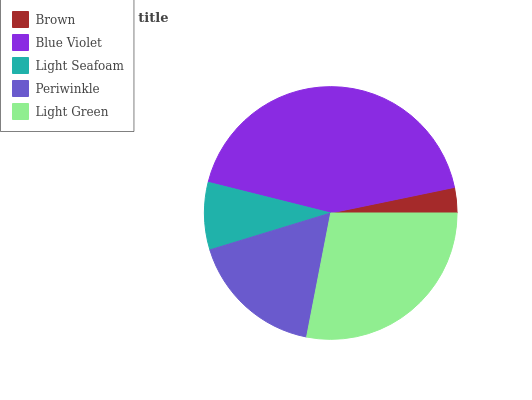Is Brown the minimum?
Answer yes or no. Yes. Is Blue Violet the maximum?
Answer yes or no. Yes. Is Light Seafoam the minimum?
Answer yes or no. No. Is Light Seafoam the maximum?
Answer yes or no. No. Is Blue Violet greater than Light Seafoam?
Answer yes or no. Yes. Is Light Seafoam less than Blue Violet?
Answer yes or no. Yes. Is Light Seafoam greater than Blue Violet?
Answer yes or no. No. Is Blue Violet less than Light Seafoam?
Answer yes or no. No. Is Periwinkle the high median?
Answer yes or no. Yes. Is Periwinkle the low median?
Answer yes or no. Yes. Is Light Green the high median?
Answer yes or no. No. Is Blue Violet the low median?
Answer yes or no. No. 